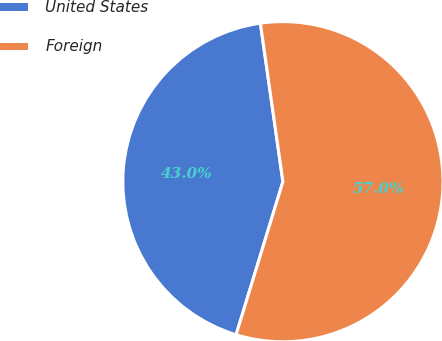Convert chart. <chart><loc_0><loc_0><loc_500><loc_500><pie_chart><fcel>United States<fcel>Foreign<nl><fcel>43.03%<fcel>56.97%<nl></chart> 